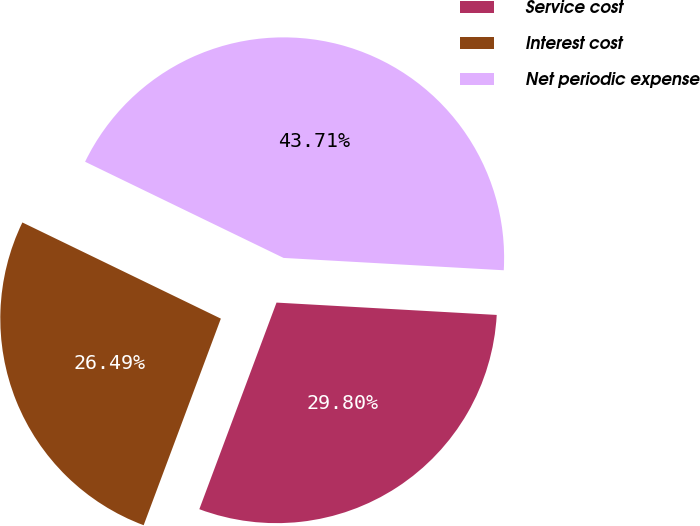<chart> <loc_0><loc_0><loc_500><loc_500><pie_chart><fcel>Service cost<fcel>Interest cost<fcel>Net periodic expense<nl><fcel>29.8%<fcel>26.49%<fcel>43.71%<nl></chart> 